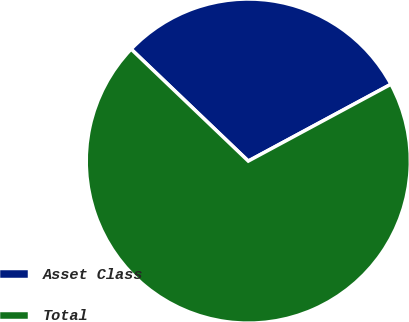Convert chart to OTSL. <chart><loc_0><loc_0><loc_500><loc_500><pie_chart><fcel>Asset Class<fcel>Total<nl><fcel>30.0%<fcel>70.0%<nl></chart> 